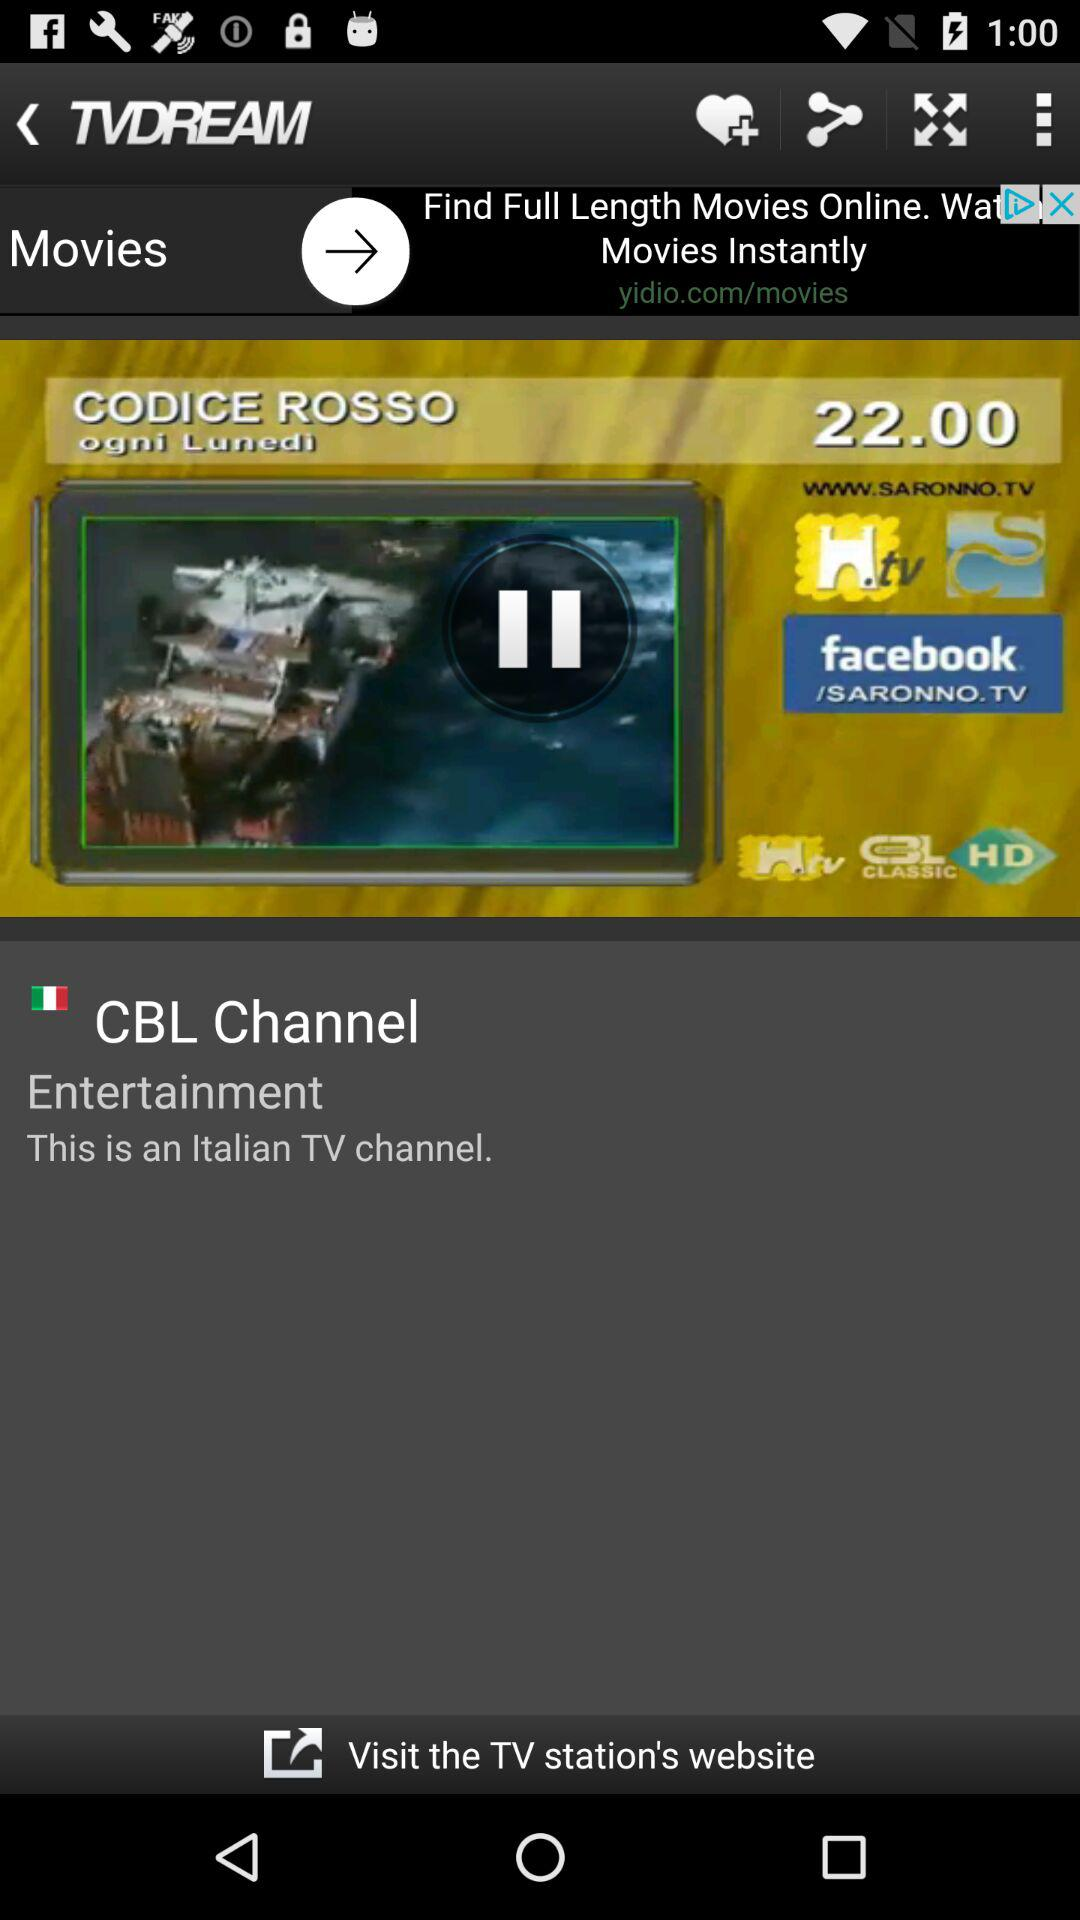What language is the channel in? The channel is in Italian. 